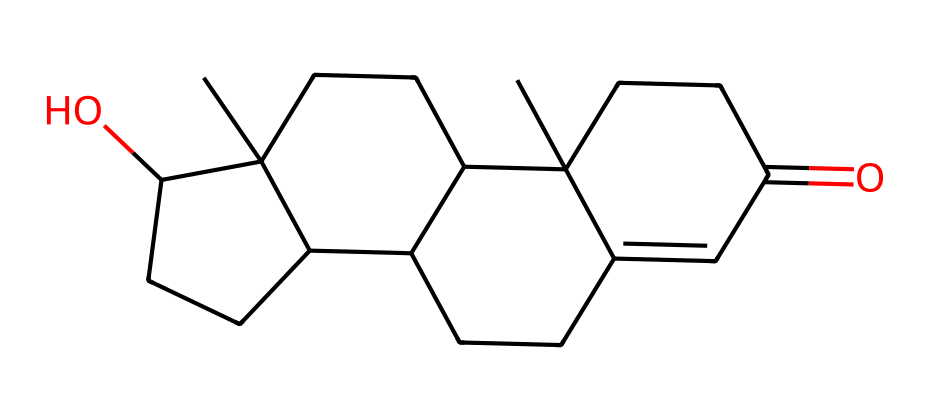What is the molecular formula of testosterone? Count the number of carbon (C), hydrogen (H), and oxygen (O) atoms in the provided SMILES representation: from CC12CCC3C(C1CCC2O)CCC4=CC(=O)CCC34C, there are 19 carbon atoms, 28 hydrogen atoms, and 2 oxygen atoms. Thus, the molecular formula is C19H28O2.
Answer: C19H28O2 How many rings are present in testosterone's structure? Analyze the condensed structure derived from the SMILES. The presence of numberings (1, 2, 3, 4) indicates the formation of multiple interconnected rings; by careful examination, it shows there are four distinct rings in total.
Answer: 4 Does testosterone have any geometric isomers? Testosterone has double bonds (noted by "=" in the SMILES), which can create cis and trans arrangements, making geometric isomerism possible. Specifically, the double bond in the structure allows for these isomers.
Answer: Yes What type of functional group is present in testosterone? Examine the SMILES for specific functional groups characterized by their structure. There is an alcohol (-OH) group as indicated by 'O' in the structure, and there is also a carbonyl group (C=O) associated with the ketone functional group.
Answer: Alcohol and ketone Which type of isomerism does testosterone exhibit? Assess the types of isomerism indicated in the chemical structure, particularly the presence of both structural and geometric isomers due to rings and double bonds, leading to the conclusion that it exhibits both types.
Answer: Both Is there a stereocenter in the testosterone structure? Determine the presence of any carbon atoms bonded to four different substituents. In this structure, look for a carbon that fits this criterion; at least one carbon does, confirming that stereocenter exists.
Answer: Yes 